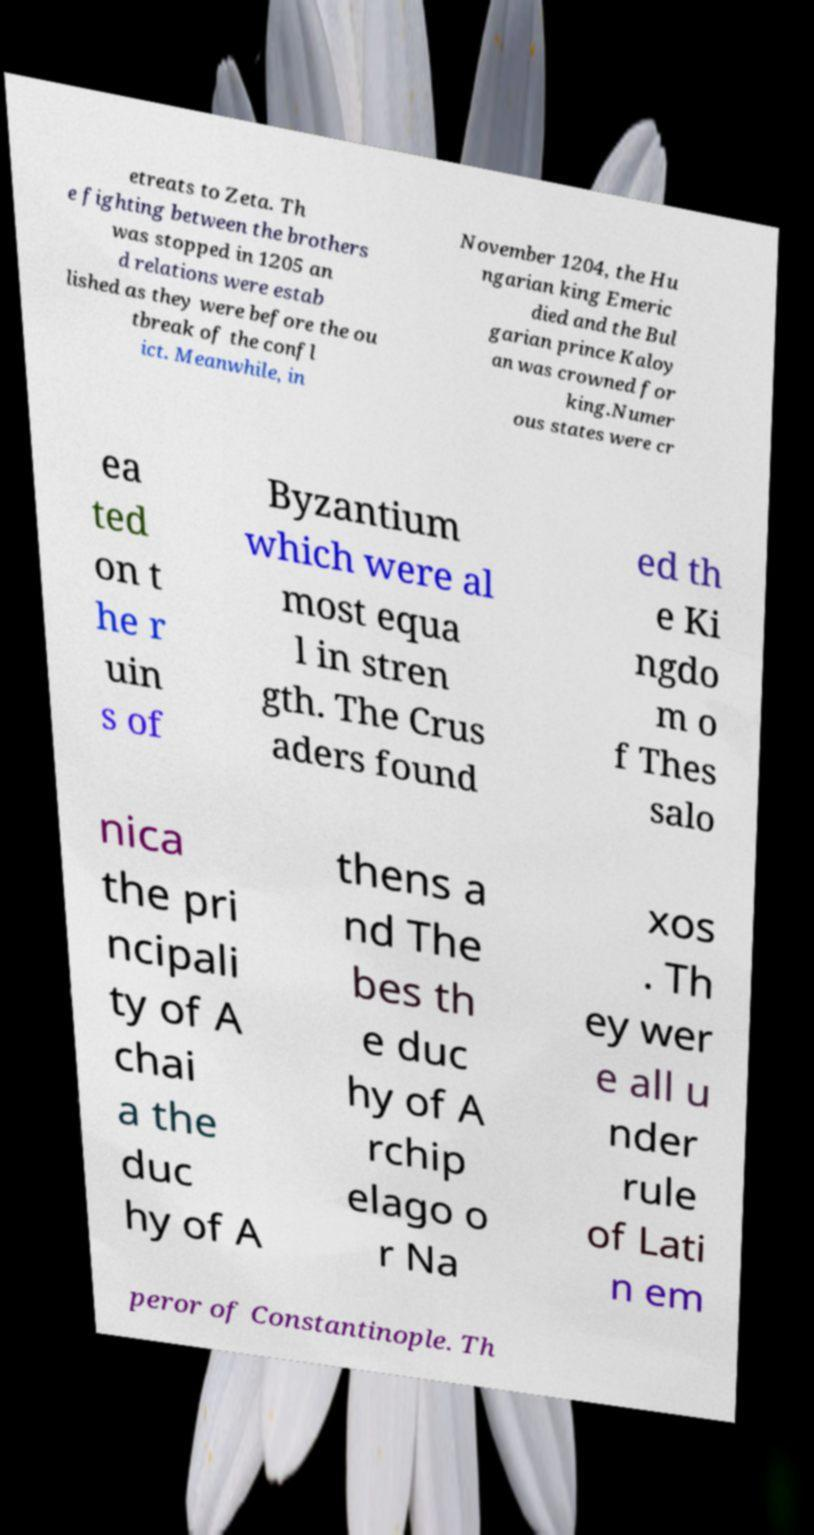Please read and relay the text visible in this image. What does it say? etreats to Zeta. Th e fighting between the brothers was stopped in 1205 an d relations were estab lished as they were before the ou tbreak of the confl ict. Meanwhile, in November 1204, the Hu ngarian king Emeric died and the Bul garian prince Kaloy an was crowned for king.Numer ous states were cr ea ted on t he r uin s of Byzantium which were al most equa l in stren gth. The Crus aders found ed th e Ki ngdo m o f Thes salo nica the pri ncipali ty of A chai a the duc hy of A thens a nd The bes th e duc hy of A rchip elago o r Na xos . Th ey wer e all u nder rule of Lati n em peror of Constantinople. Th 